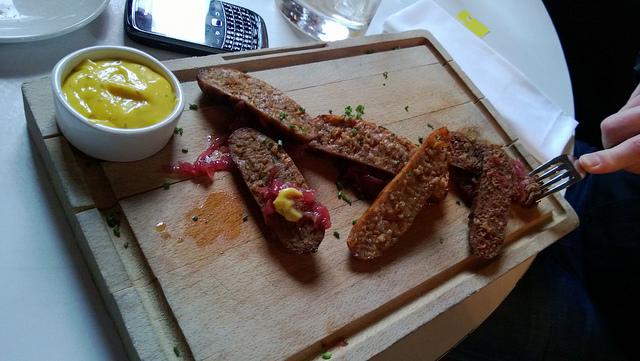What type of sauce is in the little white container?
Keep it brief. Mustard. What is the meat on?
Give a very brief answer. Cutting board. Is there one meat or two?
Keep it brief. 1. What type of mobile phone is on the table?
Give a very brief answer. Blackberry. 